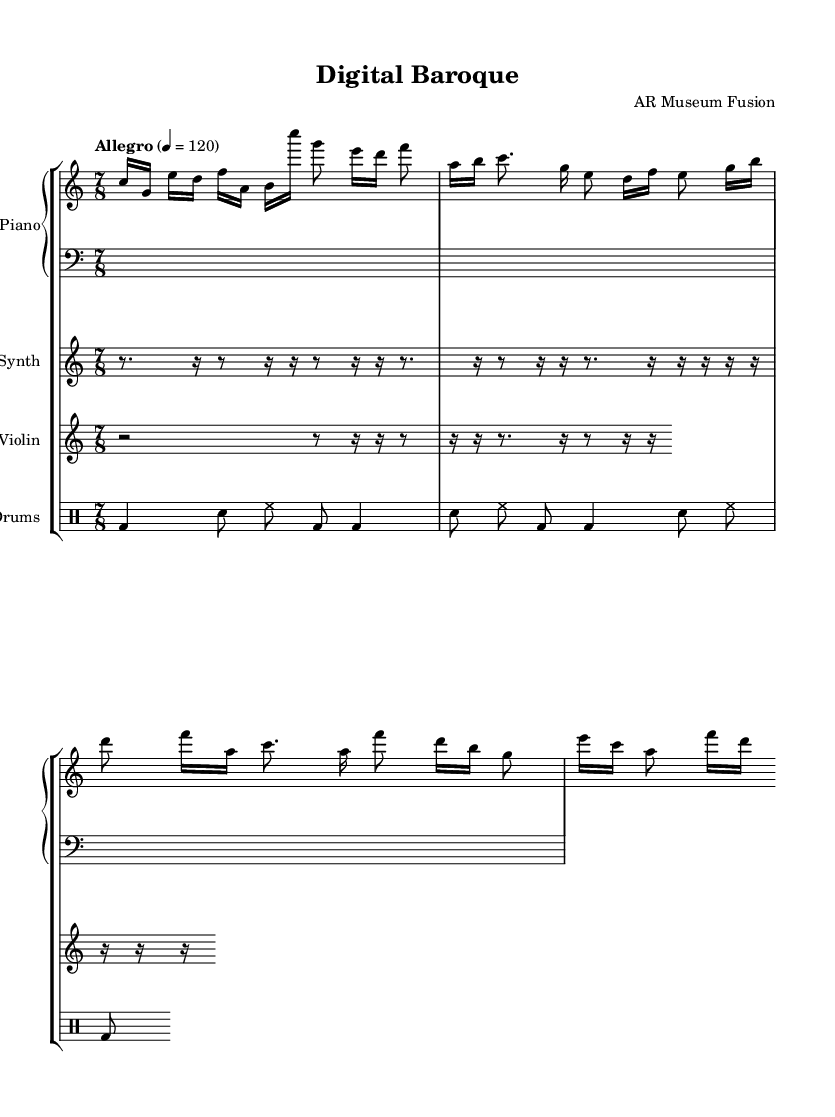What is the time signature of this music? The time signature is indicated at the beginning of the score, showing a 7 over 8, which means there are 7 beats in each measure, and the eighth note gets the beat.
Answer: 7/8 What is the tempo marking for this piece? The tempo marking is found in the score, set to "Allegro," with a metronome marking of quarter note equals 120 beats per minute, indicating a fast pace.
Answer: Allegro 4 = 120 How many musical staves are used in this score? The score displays multiple staves grouped together under different instrument headings. Counting each instrument, we find a total of 4 staves including two for piano, one for synth, one for electric violin, and one for drums.
Answer: 5 staves Which instrument plays the opening melody? The opening melody is located on the staff designated for the piano. The pitches are written first in the treble clef section of the piano part.
Answer: Piano What is the rhythmic pattern of the synth part? The synth part consists primarily of rests, evident from the absence of note values and maintaining a consistent rhythm made of eighth rests and dotted rhythms. This indicates a strong focus on silence in the texture.
Answer: Rest Which section has faster note values? The piano section presents faster note values, featuring sixteenth notes throughout its phrases, which contribute to the energetic sound of the piece.
Answer: Piano section 